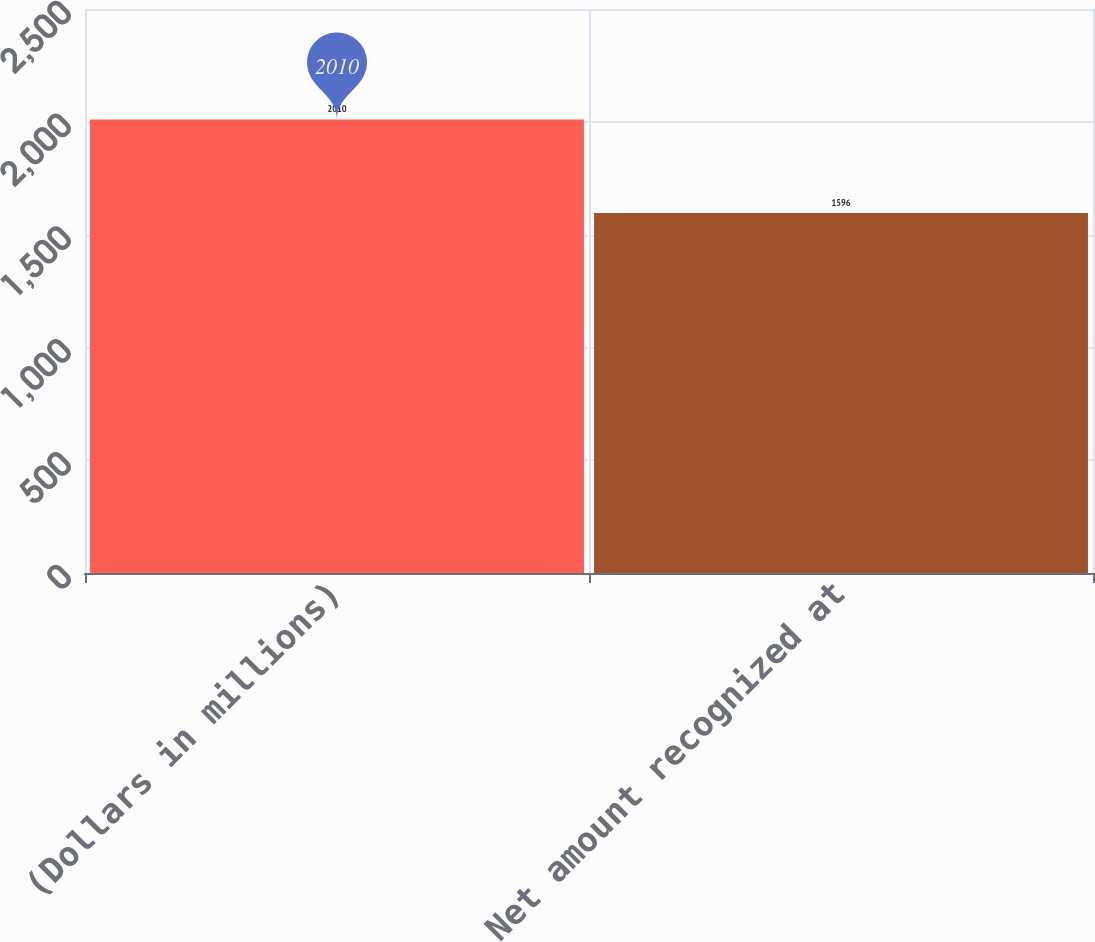<chart> <loc_0><loc_0><loc_500><loc_500><bar_chart><fcel>(Dollars in millions)<fcel>Net amount recognized at<nl><fcel>2010<fcel>1596<nl></chart> 